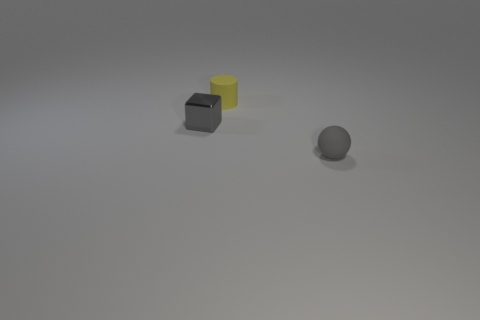Add 2 things. How many objects exist? 5 Subtract all balls. How many objects are left? 2 Subtract 1 gray spheres. How many objects are left? 2 Subtract all gray spheres. Subtract all small gray matte things. How many objects are left? 1 Add 2 tiny yellow rubber cylinders. How many tiny yellow rubber cylinders are left? 3 Add 3 cyan shiny objects. How many cyan shiny objects exist? 3 